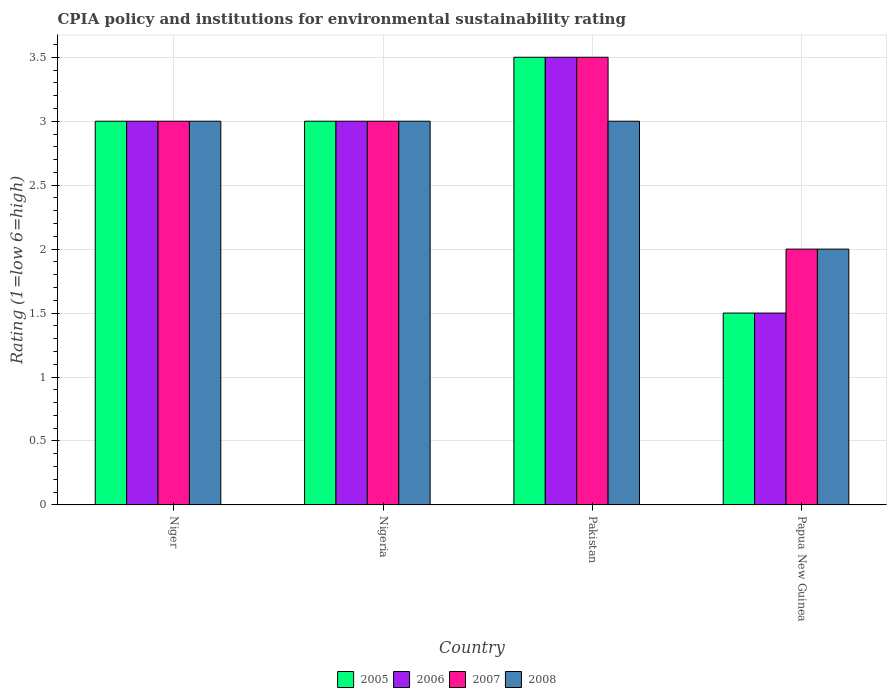How many different coloured bars are there?
Your answer should be very brief. 4. Are the number of bars on each tick of the X-axis equal?
Ensure brevity in your answer.  Yes. How many bars are there on the 3rd tick from the right?
Make the answer very short. 4. What is the label of the 2nd group of bars from the left?
Provide a succinct answer. Nigeria. What is the CPIA rating in 2007 in Niger?
Offer a terse response. 3. In which country was the CPIA rating in 2006 maximum?
Your answer should be compact. Pakistan. In which country was the CPIA rating in 2005 minimum?
Ensure brevity in your answer.  Papua New Guinea. What is the difference between the CPIA rating in 2008 in Nigeria and the CPIA rating in 2007 in Niger?
Offer a very short reply. 0. What is the average CPIA rating in 2005 per country?
Your answer should be very brief. 2.75. In how many countries, is the CPIA rating in 2007 greater than 0.5?
Ensure brevity in your answer.  4. What is the difference between the highest and the second highest CPIA rating in 2005?
Make the answer very short. -0.5. What is the difference between the highest and the lowest CPIA rating in 2006?
Your response must be concise. 2. In how many countries, is the CPIA rating in 2007 greater than the average CPIA rating in 2007 taken over all countries?
Make the answer very short. 3. Is it the case that in every country, the sum of the CPIA rating in 2006 and CPIA rating in 2007 is greater than the sum of CPIA rating in 2005 and CPIA rating in 2008?
Make the answer very short. No. Is it the case that in every country, the sum of the CPIA rating in 2007 and CPIA rating in 2006 is greater than the CPIA rating in 2005?
Your answer should be very brief. Yes. How many bars are there?
Keep it short and to the point. 16. Are all the bars in the graph horizontal?
Your response must be concise. No. Does the graph contain grids?
Ensure brevity in your answer.  Yes. Where does the legend appear in the graph?
Your answer should be very brief. Bottom center. How many legend labels are there?
Provide a short and direct response. 4. How are the legend labels stacked?
Your response must be concise. Horizontal. What is the title of the graph?
Give a very brief answer. CPIA policy and institutions for environmental sustainability rating. What is the label or title of the X-axis?
Keep it short and to the point. Country. What is the Rating (1=low 6=high) in 2006 in Niger?
Your answer should be compact. 3. What is the Rating (1=low 6=high) of 2007 in Niger?
Keep it short and to the point. 3. What is the Rating (1=low 6=high) in 2008 in Niger?
Offer a terse response. 3. What is the Rating (1=low 6=high) in 2008 in Nigeria?
Your answer should be compact. 3. What is the Rating (1=low 6=high) in 2008 in Papua New Guinea?
Offer a terse response. 2. Across all countries, what is the maximum Rating (1=low 6=high) in 2005?
Ensure brevity in your answer.  3.5. Across all countries, what is the maximum Rating (1=low 6=high) in 2006?
Give a very brief answer. 3.5. Across all countries, what is the maximum Rating (1=low 6=high) of 2008?
Your answer should be compact. 3. What is the total Rating (1=low 6=high) in 2005 in the graph?
Give a very brief answer. 11. What is the difference between the Rating (1=low 6=high) of 2008 in Niger and that in Nigeria?
Keep it short and to the point. 0. What is the difference between the Rating (1=low 6=high) of 2005 in Niger and that in Pakistan?
Offer a terse response. -0.5. What is the difference between the Rating (1=low 6=high) of 2008 in Niger and that in Pakistan?
Keep it short and to the point. 0. What is the difference between the Rating (1=low 6=high) in 2005 in Niger and that in Papua New Guinea?
Give a very brief answer. 1.5. What is the difference between the Rating (1=low 6=high) of 2005 in Nigeria and that in Pakistan?
Offer a terse response. -0.5. What is the difference between the Rating (1=low 6=high) in 2007 in Nigeria and that in Pakistan?
Offer a very short reply. -0.5. What is the difference between the Rating (1=low 6=high) of 2006 in Nigeria and that in Papua New Guinea?
Your response must be concise. 1.5. What is the difference between the Rating (1=low 6=high) of 2008 in Nigeria and that in Papua New Guinea?
Your answer should be very brief. 1. What is the difference between the Rating (1=low 6=high) of 2005 in Pakistan and that in Papua New Guinea?
Your response must be concise. 2. What is the difference between the Rating (1=low 6=high) in 2007 in Pakistan and that in Papua New Guinea?
Give a very brief answer. 1.5. What is the difference between the Rating (1=low 6=high) in 2008 in Pakistan and that in Papua New Guinea?
Keep it short and to the point. 1. What is the difference between the Rating (1=low 6=high) in 2005 in Niger and the Rating (1=low 6=high) in 2006 in Nigeria?
Give a very brief answer. 0. What is the difference between the Rating (1=low 6=high) of 2005 in Niger and the Rating (1=low 6=high) of 2007 in Nigeria?
Make the answer very short. 0. What is the difference between the Rating (1=low 6=high) of 2005 in Niger and the Rating (1=low 6=high) of 2008 in Nigeria?
Keep it short and to the point. 0. What is the difference between the Rating (1=low 6=high) in 2006 in Niger and the Rating (1=low 6=high) in 2007 in Pakistan?
Provide a succinct answer. -0.5. What is the difference between the Rating (1=low 6=high) of 2005 in Niger and the Rating (1=low 6=high) of 2006 in Papua New Guinea?
Provide a short and direct response. 1.5. What is the difference between the Rating (1=low 6=high) of 2005 in Niger and the Rating (1=low 6=high) of 2007 in Papua New Guinea?
Your answer should be compact. 1. What is the difference between the Rating (1=low 6=high) of 2005 in Niger and the Rating (1=low 6=high) of 2008 in Papua New Guinea?
Your answer should be very brief. 1. What is the difference between the Rating (1=low 6=high) of 2006 in Niger and the Rating (1=low 6=high) of 2007 in Papua New Guinea?
Your response must be concise. 1. What is the difference between the Rating (1=low 6=high) in 2005 in Nigeria and the Rating (1=low 6=high) in 2006 in Pakistan?
Offer a very short reply. -0.5. What is the difference between the Rating (1=low 6=high) in 2005 in Nigeria and the Rating (1=low 6=high) in 2007 in Pakistan?
Your response must be concise. -0.5. What is the difference between the Rating (1=low 6=high) of 2005 in Nigeria and the Rating (1=low 6=high) of 2008 in Pakistan?
Provide a short and direct response. 0. What is the difference between the Rating (1=low 6=high) of 2006 in Nigeria and the Rating (1=low 6=high) of 2008 in Pakistan?
Your answer should be compact. 0. What is the difference between the Rating (1=low 6=high) of 2007 in Nigeria and the Rating (1=low 6=high) of 2008 in Pakistan?
Keep it short and to the point. 0. What is the difference between the Rating (1=low 6=high) in 2005 in Nigeria and the Rating (1=low 6=high) in 2006 in Papua New Guinea?
Provide a succinct answer. 1.5. What is the difference between the Rating (1=low 6=high) in 2006 in Nigeria and the Rating (1=low 6=high) in 2008 in Papua New Guinea?
Your answer should be very brief. 1. What is the difference between the Rating (1=low 6=high) in 2007 in Nigeria and the Rating (1=low 6=high) in 2008 in Papua New Guinea?
Give a very brief answer. 1. What is the difference between the Rating (1=low 6=high) of 2005 in Pakistan and the Rating (1=low 6=high) of 2008 in Papua New Guinea?
Provide a short and direct response. 1.5. What is the difference between the Rating (1=low 6=high) of 2006 in Pakistan and the Rating (1=low 6=high) of 2007 in Papua New Guinea?
Give a very brief answer. 1.5. What is the difference between the Rating (1=low 6=high) in 2007 in Pakistan and the Rating (1=low 6=high) in 2008 in Papua New Guinea?
Give a very brief answer. 1.5. What is the average Rating (1=low 6=high) of 2005 per country?
Keep it short and to the point. 2.75. What is the average Rating (1=low 6=high) in 2006 per country?
Provide a short and direct response. 2.75. What is the average Rating (1=low 6=high) in 2007 per country?
Offer a terse response. 2.88. What is the average Rating (1=low 6=high) in 2008 per country?
Offer a terse response. 2.75. What is the difference between the Rating (1=low 6=high) of 2005 and Rating (1=low 6=high) of 2008 in Niger?
Ensure brevity in your answer.  0. What is the difference between the Rating (1=low 6=high) of 2006 and Rating (1=low 6=high) of 2008 in Niger?
Keep it short and to the point. 0. What is the difference between the Rating (1=low 6=high) in 2007 and Rating (1=low 6=high) in 2008 in Niger?
Provide a short and direct response. 0. What is the difference between the Rating (1=low 6=high) in 2006 and Rating (1=low 6=high) in 2007 in Nigeria?
Offer a very short reply. 0. What is the difference between the Rating (1=low 6=high) in 2005 and Rating (1=low 6=high) in 2006 in Pakistan?
Offer a terse response. 0. What is the difference between the Rating (1=low 6=high) of 2007 and Rating (1=low 6=high) of 2008 in Pakistan?
Make the answer very short. 0.5. What is the difference between the Rating (1=low 6=high) in 2005 and Rating (1=low 6=high) in 2007 in Papua New Guinea?
Ensure brevity in your answer.  -0.5. What is the difference between the Rating (1=low 6=high) in 2006 and Rating (1=low 6=high) in 2007 in Papua New Guinea?
Provide a succinct answer. -0.5. What is the ratio of the Rating (1=low 6=high) in 2005 in Niger to that in Nigeria?
Provide a short and direct response. 1. What is the ratio of the Rating (1=low 6=high) in 2007 in Niger to that in Nigeria?
Offer a very short reply. 1. What is the ratio of the Rating (1=low 6=high) in 2005 in Niger to that in Pakistan?
Offer a very short reply. 0.86. What is the ratio of the Rating (1=low 6=high) in 2006 in Niger to that in Pakistan?
Ensure brevity in your answer.  0.86. What is the ratio of the Rating (1=low 6=high) in 2006 in Niger to that in Papua New Guinea?
Make the answer very short. 2. What is the ratio of the Rating (1=low 6=high) in 2005 in Nigeria to that in Pakistan?
Give a very brief answer. 0.86. What is the ratio of the Rating (1=low 6=high) of 2007 in Nigeria to that in Pakistan?
Offer a very short reply. 0.86. What is the ratio of the Rating (1=low 6=high) in 2008 in Nigeria to that in Pakistan?
Give a very brief answer. 1. What is the ratio of the Rating (1=low 6=high) in 2008 in Nigeria to that in Papua New Guinea?
Your answer should be compact. 1.5. What is the ratio of the Rating (1=low 6=high) of 2005 in Pakistan to that in Papua New Guinea?
Keep it short and to the point. 2.33. What is the ratio of the Rating (1=low 6=high) of 2006 in Pakistan to that in Papua New Guinea?
Make the answer very short. 2.33. What is the ratio of the Rating (1=low 6=high) of 2008 in Pakistan to that in Papua New Guinea?
Your answer should be very brief. 1.5. What is the difference between the highest and the second highest Rating (1=low 6=high) in 2007?
Provide a succinct answer. 0.5. What is the difference between the highest and the second highest Rating (1=low 6=high) in 2008?
Your answer should be very brief. 0. What is the difference between the highest and the lowest Rating (1=low 6=high) in 2006?
Give a very brief answer. 2. What is the difference between the highest and the lowest Rating (1=low 6=high) of 2008?
Provide a succinct answer. 1. 